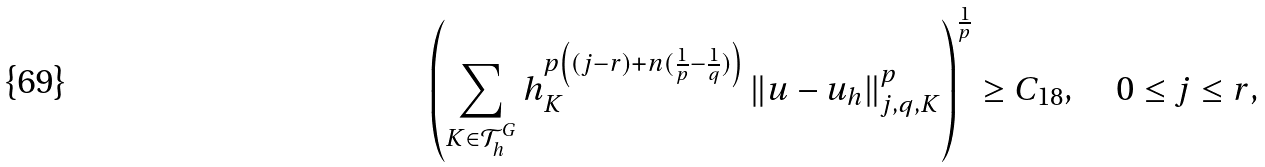Convert formula to latex. <formula><loc_0><loc_0><loc_500><loc_500>\left ( \sum _ { K \in \mathcal { T } _ { h } ^ { G } } h _ { K } ^ { p \left ( ( j - r ) + n ( \frac { 1 } { p } - \frac { 1 } { q } ) \right ) } \left \| u - u _ { h } \right \| _ { j , q , K } ^ { p } \right ) ^ { \frac { 1 } { p } } \geq C _ { 1 8 } , \quad 0 \leq j \leq r ,</formula> 